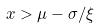<formula> <loc_0><loc_0><loc_500><loc_500>x > \mu - \sigma / \xi</formula> 